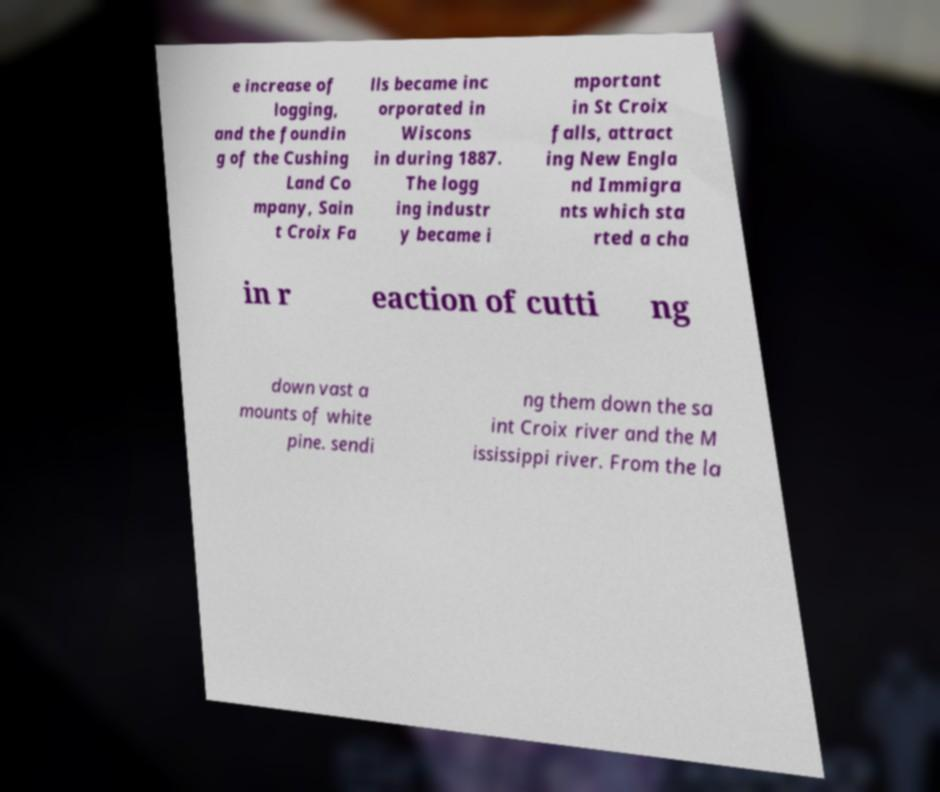Could you extract and type out the text from this image? e increase of logging, and the foundin g of the Cushing Land Co mpany, Sain t Croix Fa lls became inc orporated in Wiscons in during 1887. The logg ing industr y became i mportant in St Croix falls, attract ing New Engla nd Immigra nts which sta rted a cha in r eaction of cutti ng down vast a mounts of white pine. sendi ng them down the sa int Croix river and the M ississippi river. From the la 